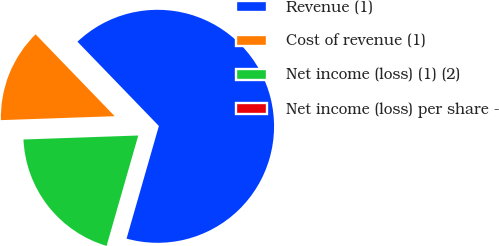<chart> <loc_0><loc_0><loc_500><loc_500><pie_chart><fcel>Revenue (1)<fcel>Cost of revenue (1)<fcel>Net income (loss) (1) (2)<fcel>Net income (loss) per share -<nl><fcel>66.67%<fcel>13.33%<fcel>20.0%<fcel>0.0%<nl></chart> 